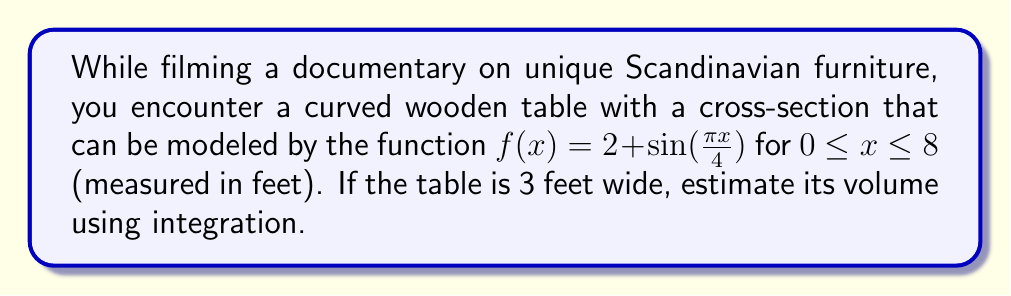Show me your answer to this math problem. To estimate the volume of the curved wooden table, we need to use the method of integration. Here's a step-by-step approach:

1. The volume of a solid with a variable cross-sectional area can be calculated using the formula:

   $$V = \int_a^b A(x) dx$$

   where $A(x)$ is the area of the cross-section at position $x$.

2. In this case, the cross-sectional area at any point $x$ is a rectangle with:
   - Width = 3 feet (constant)
   - Height = $f(x) = 2 + \sin(\frac{\pi x}{4})$ feet

3. Therefore, the area function $A(x)$ is:

   $$A(x) = 3 \cdot f(x) = 3(2 + \sin(\frac{\pi x}{4}))$$

4. Now we can set up our integral:

   $$V = \int_0^8 3(2 + \sin(\frac{\pi x}{4})) dx$$

5. Simplify the integrand:

   $$V = \int_0^8 (6 + 3\sin(\frac{\pi x}{4})) dx$$

6. Integrate:

   $$V = [6x - \frac{12}{\pi}\cos(\frac{\pi x}{4})]_0^8$$

7. Evaluate the integral:

   $$V = (48 - \frac{12}{\pi}\cos(2\pi)) - (0 - \frac{12}{\pi}\cos(0))$$
   $$V = 48 - \frac{12}{\pi}\cos(2\pi) + \frac{12}{\pi}$$
   $$V = 48 + \frac{12}{\pi}$$

8. Calculate the final result:

   $$V \approx 51.82 \text{ cubic feet}$$
Answer: $51.82 \text{ ft}^3$ 